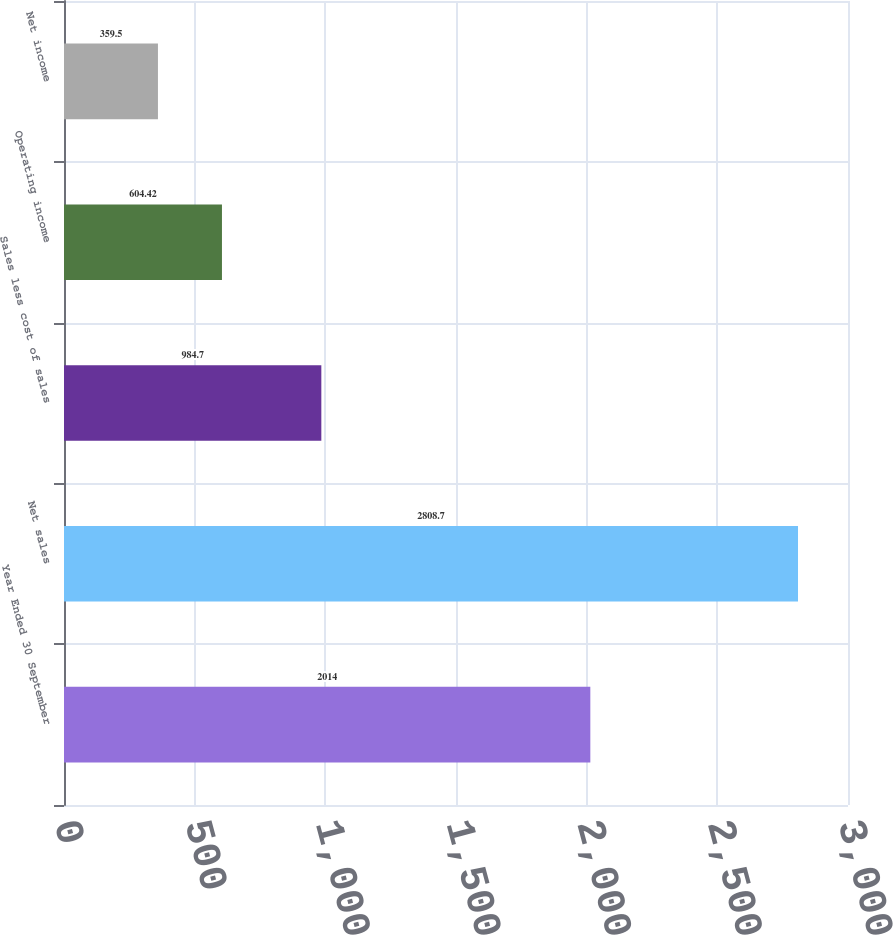Convert chart to OTSL. <chart><loc_0><loc_0><loc_500><loc_500><bar_chart><fcel>Year Ended 30 September<fcel>Net sales<fcel>Sales less cost of sales<fcel>Operating income<fcel>Net income<nl><fcel>2014<fcel>2808.7<fcel>984.7<fcel>604.42<fcel>359.5<nl></chart> 